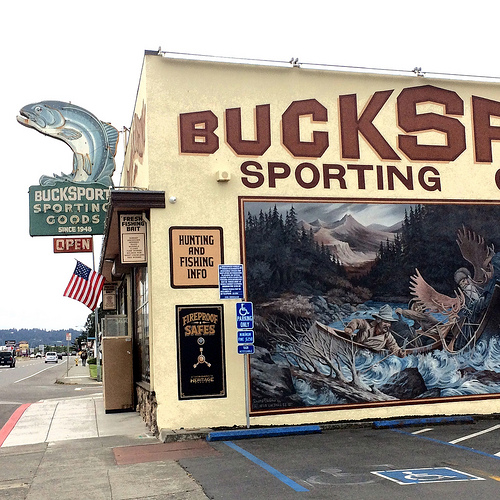<image>
Can you confirm if the flag is under the fish? Yes. The flag is positioned underneath the fish, with the fish above it in the vertical space. Is the sign above the poster? No. The sign is not positioned above the poster. The vertical arrangement shows a different relationship. 